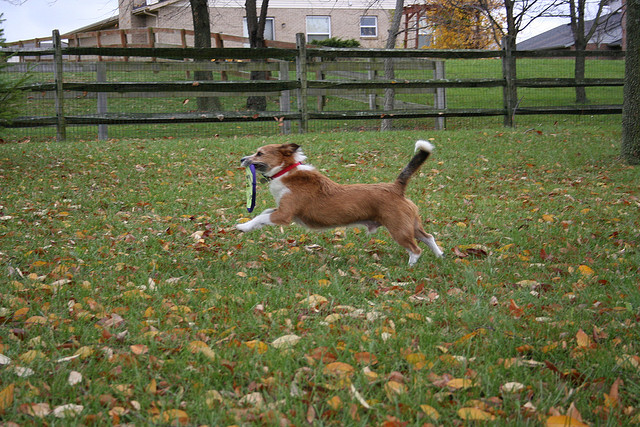<image>What kind of dog is that? I'm not sure about the breed of the dog. It can be anything from a 'mutt', 'russell terrier mix', 'corgi', to a 'collie'. What kind of dog is that? I don't know what kind of dog it is. It can be a mutt, a russell terrier mix, a corgi, a collie, or a terrier. 